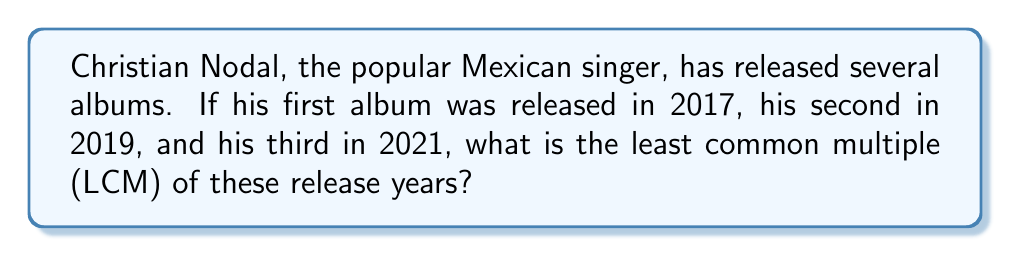Help me with this question. To find the LCM of 2017, 2019, and 2021, let's follow these steps:

1) First, let's factor each number:
   
   $2017 = 7 \times 17 \times 17$
   $2019 = 3 \times 673$
   $2021 = 43 \times 47$

2) The LCM will include the highest power of each prime factor found in any of the numbers.

3) We can express this mathematically as:

   $LCM(2017, 2019, 2021) = 7 \times 17^2 \times 3 \times 673 \times 43 \times 47$

4) Now let's calculate this:

   $7 \times 289 \times 3 \times 673 \times 43 \times 47$
   $= 2017 \times 3 \times 673 \times 43 \times 47$
   $= 2017 \times 2019 \times 43 \times 47$
   $= 4072323 \times 2021$
   $= 8,230,164,783$

Therefore, the least common multiple of 2017, 2019, and 2021 is 8,230,164,783.
Answer: 8,230,164,783 